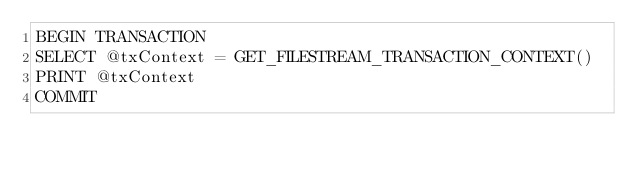Convert code to text. <code><loc_0><loc_0><loc_500><loc_500><_SQL_>BEGIN TRANSACTION
SELECT @txContext = GET_FILESTREAM_TRANSACTION_CONTEXT()
PRINT @txContext
COMMIT</code> 